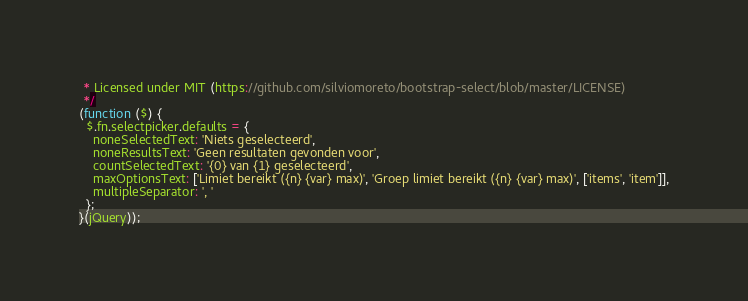Convert code to text. <code><loc_0><loc_0><loc_500><loc_500><_JavaScript_> * Licensed under MIT (https://github.com/silviomoreto/bootstrap-select/blob/master/LICENSE)
 */
(function ($) {
  $.fn.selectpicker.defaults = {
    noneSelectedText: 'Niets geselecteerd',
    noneResultsText: 'Geen resultaten gevonden voor',
    countSelectedText: '{0} van {1} geselecteerd',
    maxOptionsText: ['Limiet bereikt ({n} {var} max)', 'Groep limiet bereikt ({n} {var} max)', ['items', 'item']],
    multipleSeparator: ', '
  };
}(jQuery));
</code> 